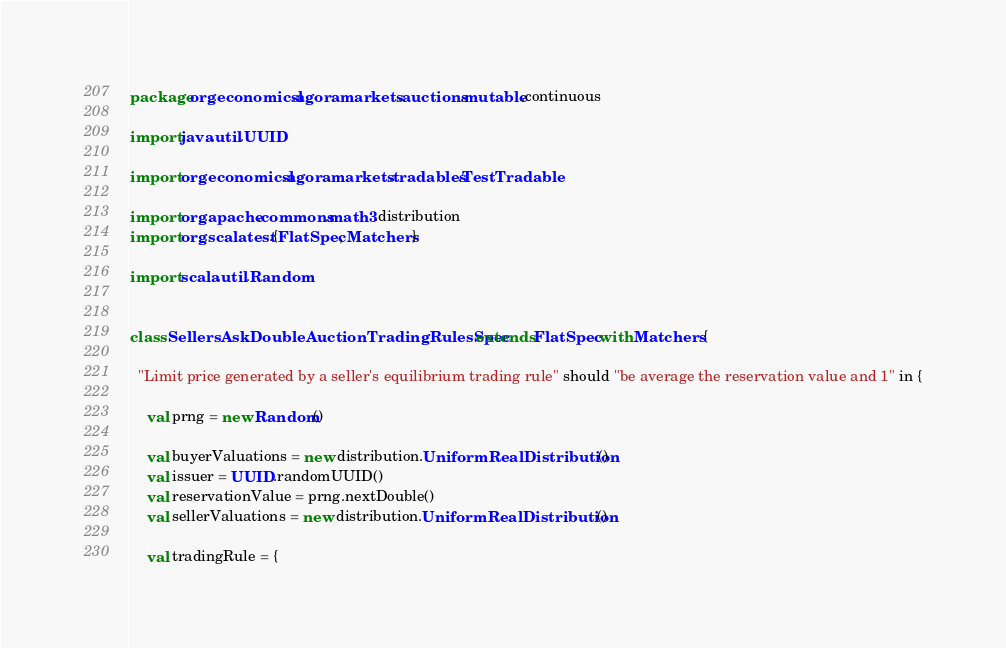<code> <loc_0><loc_0><loc_500><loc_500><_Scala_>package org.economicsl.agora.markets.auctions.mutable.continuous

import java.util.UUID

import org.economicsl.agora.markets.tradables.TestTradable

import org.apache.commons.math3.distribution
import org.scalatest.{FlatSpec, Matchers}

import scala.util.Random


class SellersAskDoubleAuctionTradingRulesSpec extends FlatSpec with Matchers {

  "Limit price generated by a seller's equilibrium trading rule" should "be average the reservation value and 1" in {

    val prng = new Random()

    val buyerValuations = new distribution.UniformRealDistribution()
    val issuer = UUID.randomUUID()
    val reservationValue = prng.nextDouble()
    val sellerValuations = new distribution.UniformRealDistribution()

    val tradingRule = {</code> 